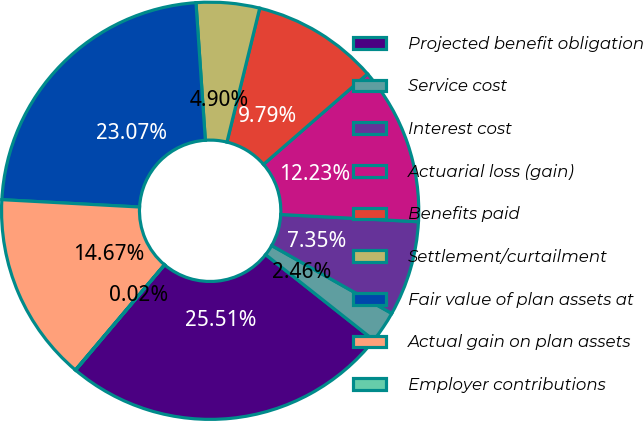Convert chart to OTSL. <chart><loc_0><loc_0><loc_500><loc_500><pie_chart><fcel>Projected benefit obligation<fcel>Service cost<fcel>Interest cost<fcel>Actuarial loss (gain)<fcel>Benefits paid<fcel>Settlement/curtailment<fcel>Fair value of plan assets at<fcel>Actual gain on plan assets<fcel>Employer contributions<nl><fcel>25.51%<fcel>2.46%<fcel>7.35%<fcel>12.23%<fcel>9.79%<fcel>4.9%<fcel>23.07%<fcel>14.67%<fcel>0.02%<nl></chart> 